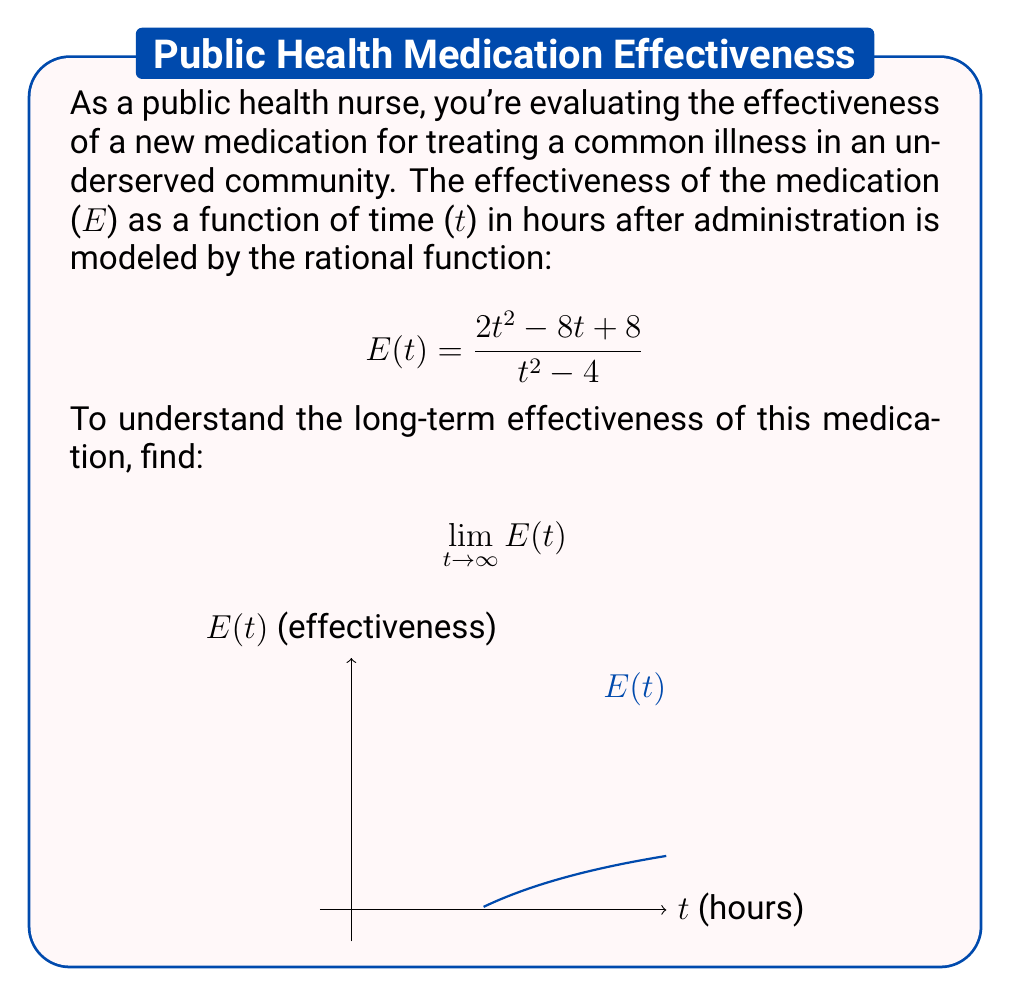Give your solution to this math problem. To find the limit as t approaches infinity, we'll follow these steps:

1) First, we need to look at the highest degree terms in the numerator and denominator:

   $$\lim_{t \to \infty} \frac{2t^2 - 8t + 8}{t^2 - 4}$$

2) The highest degree in both numerator and denominator is 2, so we can divide both top and bottom by $t^2$:

   $$\lim_{t \to \infty} \frac{2t^2/t^2 - 8t/t^2 + 8/t^2}{t^2/t^2 - 4/t^2}$$

3) Simplify:

   $$\lim_{t \to \infty} \frac{2 - 8/t + 8/t^2}{1 - 4/t^2}$$

4) As t approaches infinity, $1/t$ and $1/t^2$ approach 0:

   $$\lim_{t \to \infty} \frac{2 - 0 + 0}{1 - 0} = \frac{2}{1} = 2$$

5) Therefore, the long-term effectiveness of the medication approaches 2 as time increases indefinitely.
Answer: $2$ 